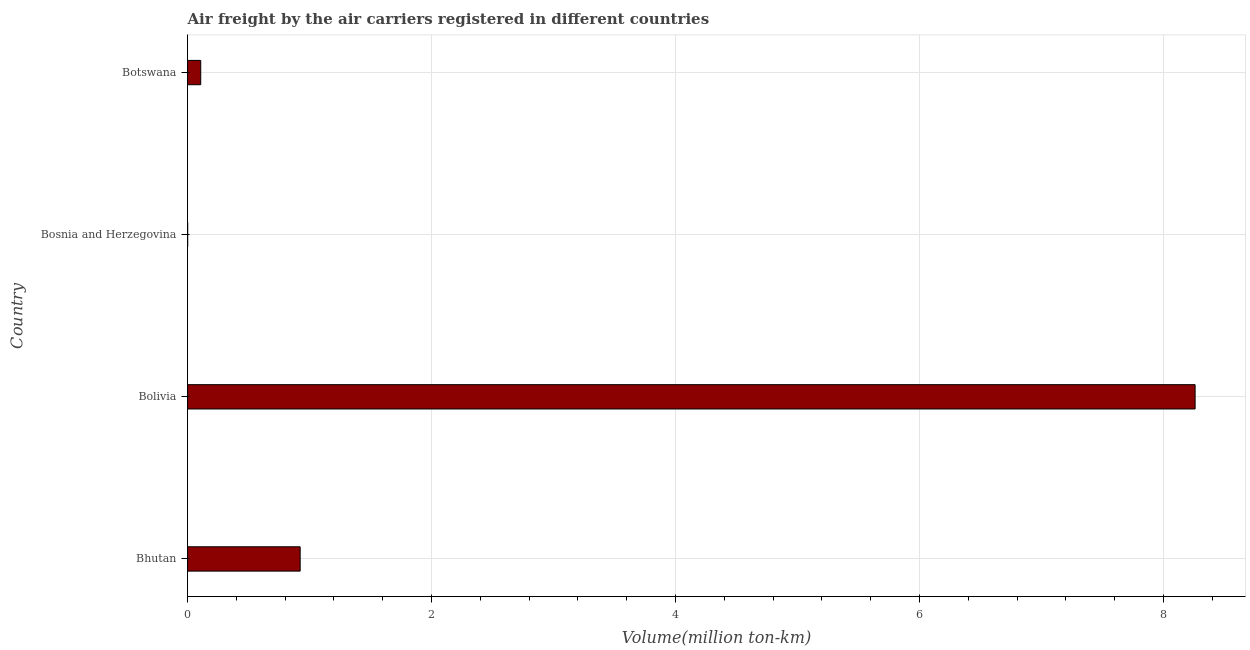Does the graph contain any zero values?
Your response must be concise. No. Does the graph contain grids?
Offer a very short reply. Yes. What is the title of the graph?
Keep it short and to the point. Air freight by the air carriers registered in different countries. What is the label or title of the X-axis?
Your answer should be compact. Volume(million ton-km). What is the air freight in Bolivia?
Your answer should be very brief. 8.26. Across all countries, what is the maximum air freight?
Your response must be concise. 8.26. Across all countries, what is the minimum air freight?
Provide a short and direct response. 0. In which country was the air freight minimum?
Make the answer very short. Bosnia and Herzegovina. What is the sum of the air freight?
Your response must be concise. 9.29. What is the difference between the air freight in Bosnia and Herzegovina and Botswana?
Make the answer very short. -0.11. What is the average air freight per country?
Ensure brevity in your answer.  2.32. What is the median air freight?
Provide a succinct answer. 0.52. What is the ratio of the air freight in Bolivia to that in Bosnia and Herzegovina?
Provide a short and direct response. 2.02e+04. Is the air freight in Bosnia and Herzegovina less than that in Botswana?
Keep it short and to the point. Yes. What is the difference between the highest and the second highest air freight?
Keep it short and to the point. 7.34. What is the difference between the highest and the lowest air freight?
Your answer should be very brief. 8.26. In how many countries, is the air freight greater than the average air freight taken over all countries?
Provide a succinct answer. 1. Are all the bars in the graph horizontal?
Provide a short and direct response. Yes. How many countries are there in the graph?
Your response must be concise. 4. What is the Volume(million ton-km) of Bhutan?
Your response must be concise. 0.92. What is the Volume(million ton-km) of Bolivia?
Give a very brief answer. 8.26. What is the Volume(million ton-km) in Bosnia and Herzegovina?
Offer a very short reply. 0. What is the Volume(million ton-km) of Botswana?
Your response must be concise. 0.11. What is the difference between the Volume(million ton-km) in Bhutan and Bolivia?
Keep it short and to the point. -7.34. What is the difference between the Volume(million ton-km) in Bhutan and Bosnia and Herzegovina?
Your response must be concise. 0.92. What is the difference between the Volume(million ton-km) in Bhutan and Botswana?
Make the answer very short. 0.82. What is the difference between the Volume(million ton-km) in Bolivia and Bosnia and Herzegovina?
Your answer should be compact. 8.26. What is the difference between the Volume(million ton-km) in Bolivia and Botswana?
Offer a terse response. 8.15. What is the difference between the Volume(million ton-km) in Bosnia and Herzegovina and Botswana?
Your answer should be very brief. -0.11. What is the ratio of the Volume(million ton-km) in Bhutan to that in Bolivia?
Keep it short and to the point. 0.11. What is the ratio of the Volume(million ton-km) in Bhutan to that in Bosnia and Herzegovina?
Your answer should be very brief. 2259.58. What is the ratio of the Volume(million ton-km) in Bhutan to that in Botswana?
Offer a very short reply. 8.57. What is the ratio of the Volume(million ton-km) in Bolivia to that in Bosnia and Herzegovina?
Ensure brevity in your answer.  2.02e+04. What is the ratio of the Volume(million ton-km) in Bolivia to that in Botswana?
Ensure brevity in your answer.  76.67. What is the ratio of the Volume(million ton-km) in Bosnia and Herzegovina to that in Botswana?
Give a very brief answer. 0. 